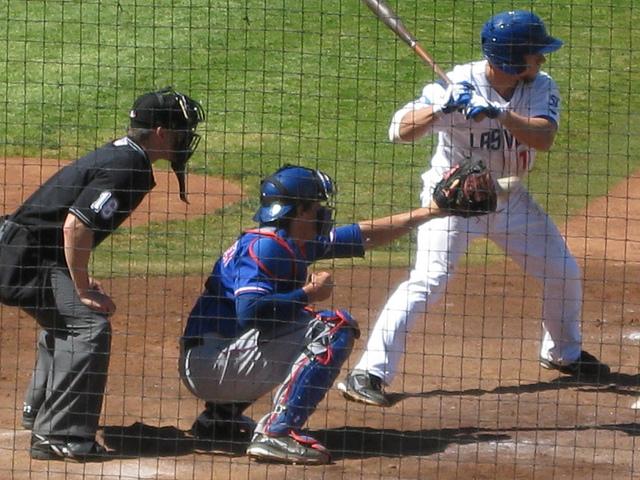What is the man wearing blue doing?
Answer briefly. Catching. Where is the batter?
Write a very short answer. In front. What is the number on the black shirt?
Write a very short answer. 18. 